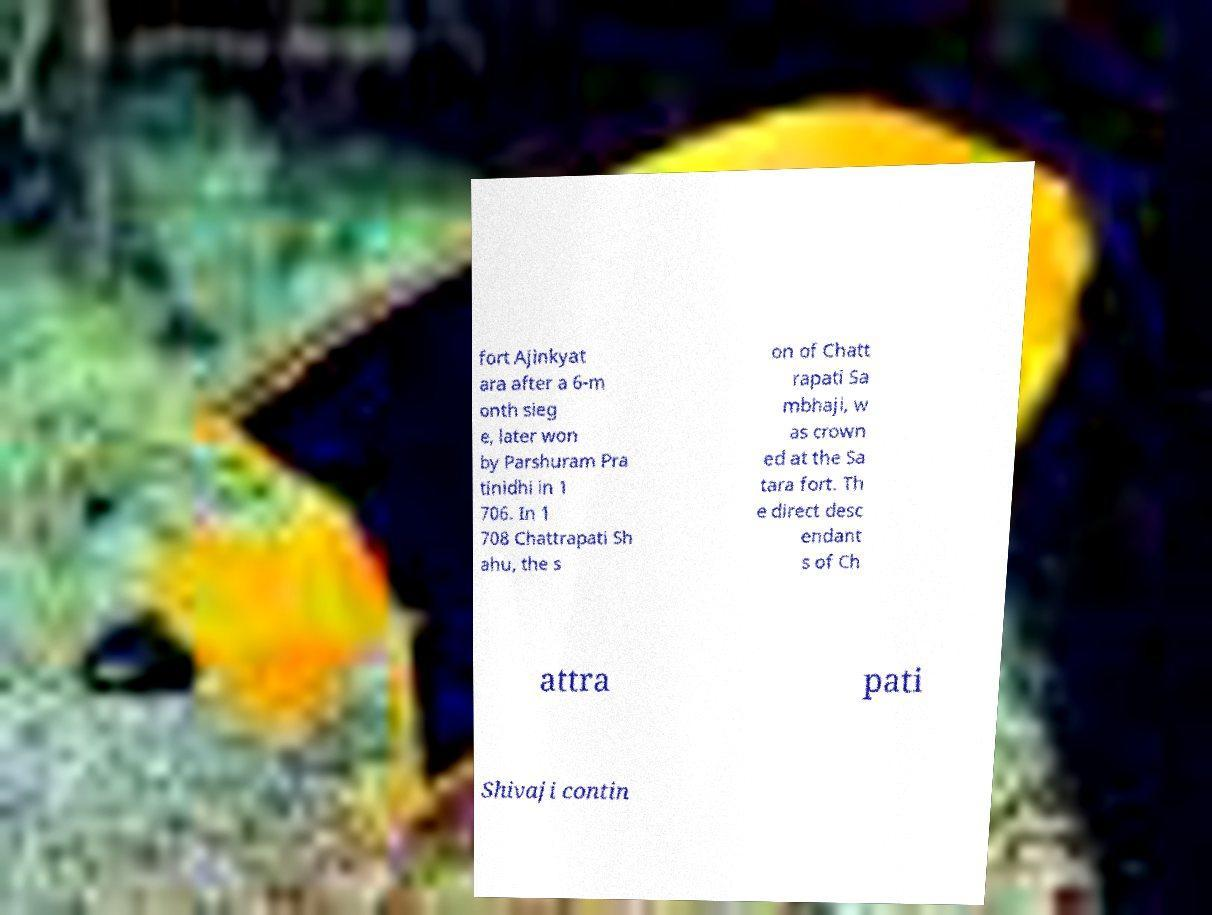Please identify and transcribe the text found in this image. fort Ajinkyat ara after a 6-m onth sieg e, later won by Parshuram Pra tinidhi in 1 706. In 1 708 Chattrapati Sh ahu, the s on of Chatt rapati Sa mbhaji, w as crown ed at the Sa tara fort. Th e direct desc endant s of Ch attra pati Shivaji contin 